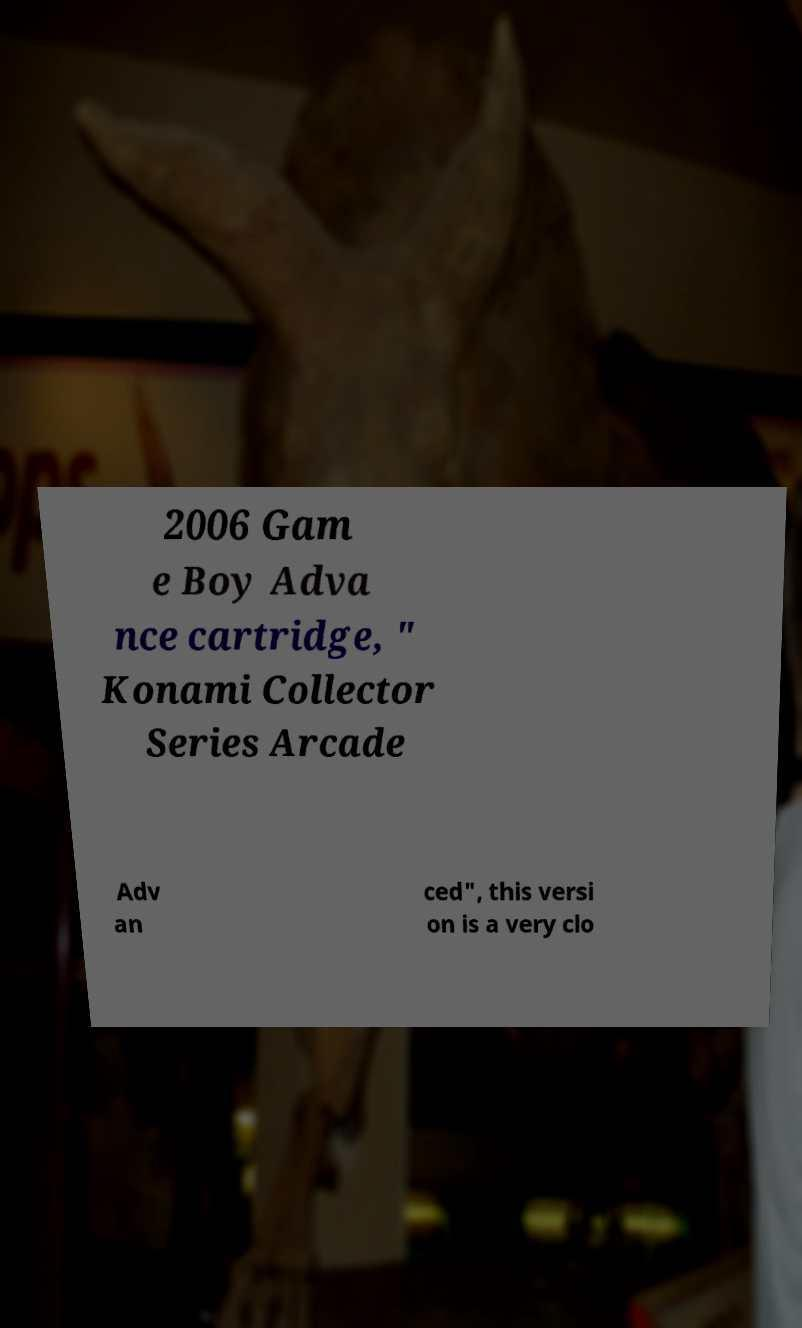For documentation purposes, I need the text within this image transcribed. Could you provide that? 2006 Gam e Boy Adva nce cartridge, " Konami Collector Series Arcade Adv an ced", this versi on is a very clo 